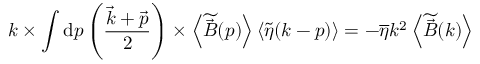Convert formula to latex. <formula><loc_0><loc_0><loc_500><loc_500>k \times \int d p \left ( \frac { \vec { k } + \vec { p } } { 2 } \right ) \times \left < \widetilde { \vec { B } } ( p ) \right > \left < \widetilde { \eta } ( k - p ) \right > = - \overline { \eta } k ^ { 2 } \left < \widetilde { \vec { B } } ( k ) \right ></formula> 